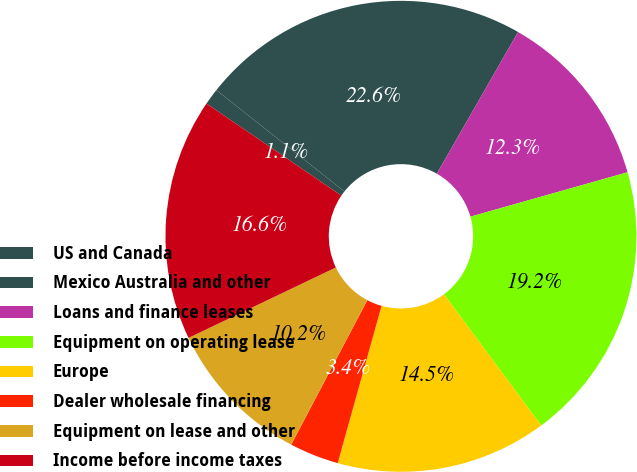<chart> <loc_0><loc_0><loc_500><loc_500><pie_chart><fcel>US and Canada<fcel>Mexico Australia and other<fcel>Loans and finance leases<fcel>Equipment on operating lease<fcel>Europe<fcel>Dealer wholesale financing<fcel>Equipment on lease and other<fcel>Income before income taxes<nl><fcel>1.13%<fcel>22.62%<fcel>12.33%<fcel>19.23%<fcel>14.48%<fcel>3.39%<fcel>10.18%<fcel>16.63%<nl></chart> 